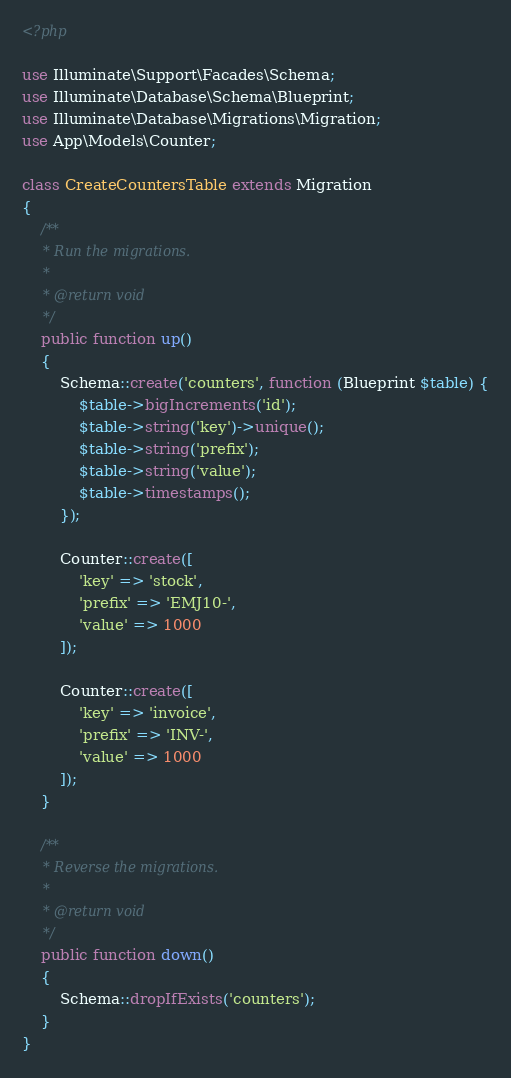<code> <loc_0><loc_0><loc_500><loc_500><_PHP_><?php

use Illuminate\Support\Facades\Schema;
use Illuminate\Database\Schema\Blueprint;
use Illuminate\Database\Migrations\Migration;
use App\Models\Counter;

class CreateCountersTable extends Migration
{
    /**
     * Run the migrations.
     *
     * @return void
     */
    public function up()
    {
        Schema::create('counters', function (Blueprint $table) {
            $table->bigIncrements('id');
            $table->string('key')->unique();
            $table->string('prefix');
            $table->string('value');
            $table->timestamps();
        });

        Counter::create([
            'key' => 'stock',
            'prefix' => 'EMJ10-',
            'value' => 1000
        ]);

        Counter::create([
            'key' => 'invoice',
            'prefix' => 'INV-',
            'value' => 1000
        ]);
    }

    /**
     * Reverse the migrations.
     *
     * @return void
     */
    public function down()
    {
        Schema::dropIfExists('counters');
    }
}
</code> 